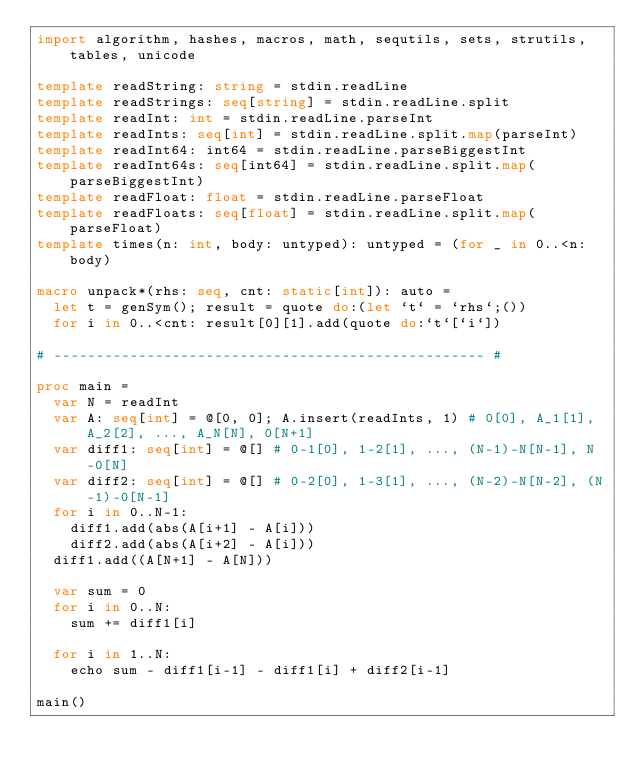Convert code to text. <code><loc_0><loc_0><loc_500><loc_500><_Nim_>import algorithm, hashes, macros, math, sequtils, sets, strutils, tables, unicode

template readString: string = stdin.readLine
template readStrings: seq[string] = stdin.readLine.split
template readInt: int = stdin.readLine.parseInt
template readInts: seq[int] = stdin.readLine.split.map(parseInt)
template readInt64: int64 = stdin.readLine.parseBiggestInt
template readInt64s: seq[int64] = stdin.readLine.split.map(parseBiggestInt)
template readFloat: float = stdin.readLine.parseFloat
template readFloats: seq[float] = stdin.readLine.split.map(parseFloat)
template times(n: int, body: untyped): untyped = (for _ in 0..<n: body)

macro unpack*(rhs: seq, cnt: static[int]): auto =
  let t = genSym(); result = quote do:(let `t` = `rhs`;())
  for i in 0..<cnt: result[0][1].add(quote do:`t`[`i`])

# --------------------------------------------------- #

proc main =
  var N = readInt
  var A: seq[int] = @[0, 0]; A.insert(readInts, 1) # 0[0], A_1[1], A_2[2], ..., A_N[N], 0[N+1]
  var diff1: seq[int] = @[] # 0-1[0], 1-2[1], ..., (N-1)-N[N-1], N-0[N]
  var diff2: seq[int] = @[] # 0-2[0], 1-3[1], ..., (N-2)-N[N-2], (N-1)-0[N-1]
  for i in 0..N-1:
    diff1.add(abs(A[i+1] - A[i]))
    diff2.add(abs(A[i+2] - A[i]))
  diff1.add((A[N+1] - A[N]))

  var sum = 0
  for i in 0..N:
    sum += diff1[i]
  
  for i in 1..N:
    echo sum - diff1[i-1] - diff1[i] + diff2[i-1]

main()</code> 